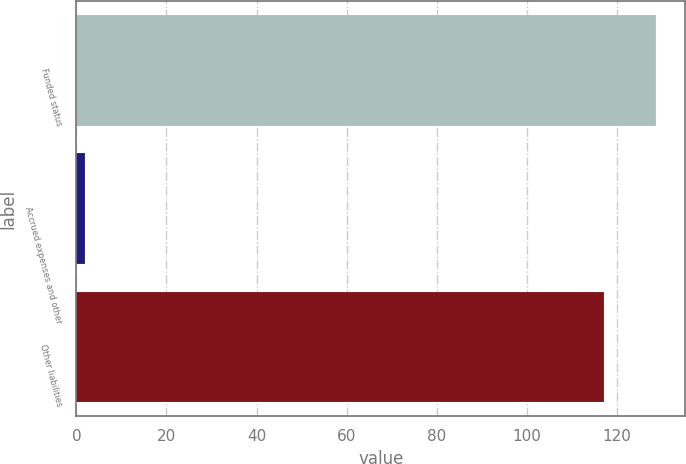Convert chart. <chart><loc_0><loc_0><loc_500><loc_500><bar_chart><fcel>Funded status<fcel>Accrued expenses and other<fcel>Other liabilities<nl><fcel>128.7<fcel>2<fcel>117<nl></chart> 